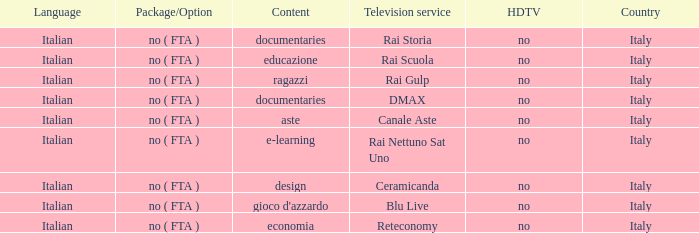Give me the full table as a dictionary. {'header': ['Language', 'Package/Option', 'Content', 'Television service', 'HDTV', 'Country'], 'rows': [['Italian', 'no ( FTA )', 'documentaries', 'Rai Storia', 'no', 'Italy'], ['Italian', 'no ( FTA )', 'educazione', 'Rai Scuola', 'no', 'Italy'], ['Italian', 'no ( FTA )', 'ragazzi', 'Rai Gulp', 'no', 'Italy'], ['Italian', 'no ( FTA )', 'documentaries', 'DMAX', 'no', 'Italy'], ['Italian', 'no ( FTA )', 'aste', 'Canale Aste', 'no', 'Italy'], ['Italian', 'no ( FTA )', 'e-learning', 'Rai Nettuno Sat Uno', 'no', 'Italy'], ['Italian', 'no ( FTA )', 'design', 'Ceramicanda', 'no', 'Italy'], ['Italian', 'no ( FTA )', "gioco d'azzardo", 'Blu Live', 'no', 'Italy'], ['Italian', 'no ( FTA )', 'economia', 'Reteconomy', 'no', 'Italy']]} What is the HDTV for the Rai Nettuno Sat Uno Television service? No. 